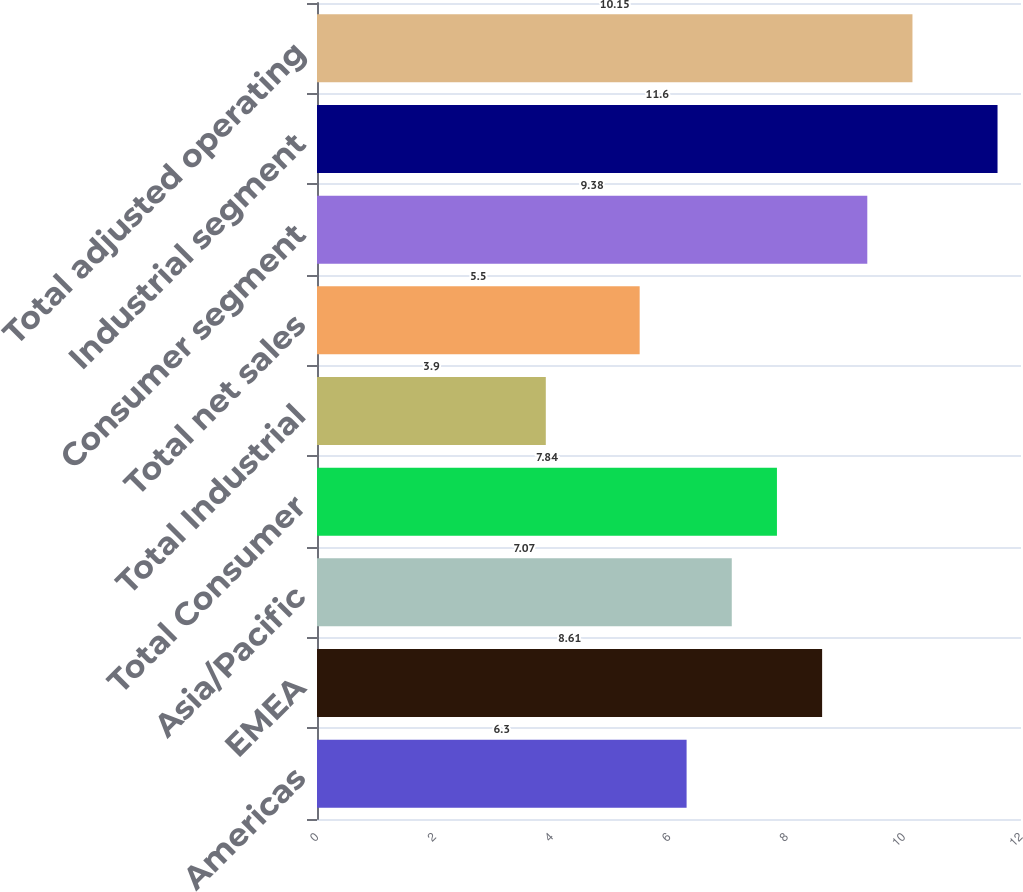<chart> <loc_0><loc_0><loc_500><loc_500><bar_chart><fcel>Americas<fcel>EMEA<fcel>Asia/Pacific<fcel>Total Consumer<fcel>Total Industrial<fcel>Total net sales<fcel>Consumer segment<fcel>Industrial segment<fcel>Total adjusted operating<nl><fcel>6.3<fcel>8.61<fcel>7.07<fcel>7.84<fcel>3.9<fcel>5.5<fcel>9.38<fcel>11.6<fcel>10.15<nl></chart> 